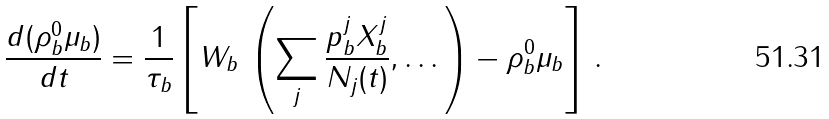<formula> <loc_0><loc_0><loc_500><loc_500>\frac { d ( \rho _ { b } ^ { 0 } \mu _ { b } ) } { d t } = \frac { 1 } { \tau _ { b } } \left [ W _ { b } \, \left ( \sum _ { j } \frac { p _ { b } ^ { j } X _ { b } ^ { j } } { N _ { j } ( t ) } , \dots \right ) - \rho _ { b } ^ { 0 } \mu _ { b } \right ] \, .</formula> 